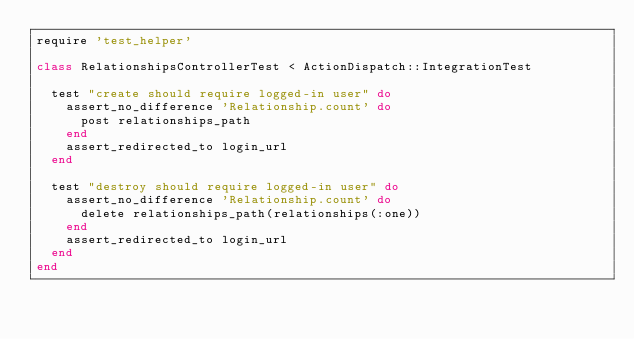Convert code to text. <code><loc_0><loc_0><loc_500><loc_500><_Ruby_>require 'test_helper'

class RelationshipsControllerTest < ActionDispatch::IntegrationTest

  test "create should require logged-in user" do
    assert_no_difference 'Relationship.count' do
      post relationships_path
    end
    assert_redirected_to login_url
  end

  test "destroy should require logged-in user" do
    assert_no_difference 'Relationship.count' do
      delete relationships_path(relationships(:one))
    end
    assert_redirected_to login_url
  end
end
</code> 